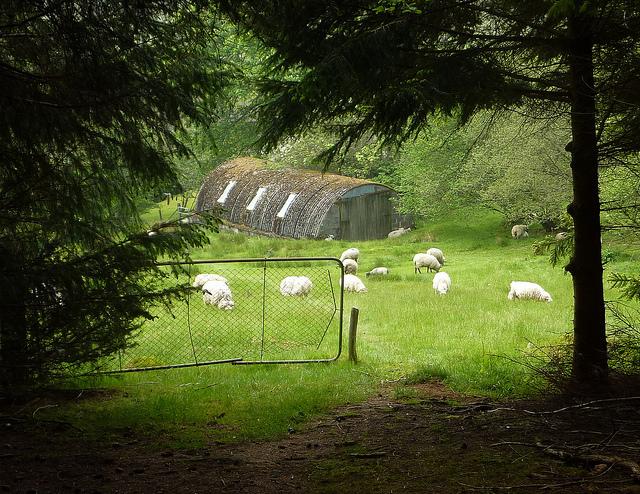Do they have water?
Be succinct. No. Can the sheep escape?
Give a very brief answer. Yes. What is the roof made of?
Keep it brief. Metal. 